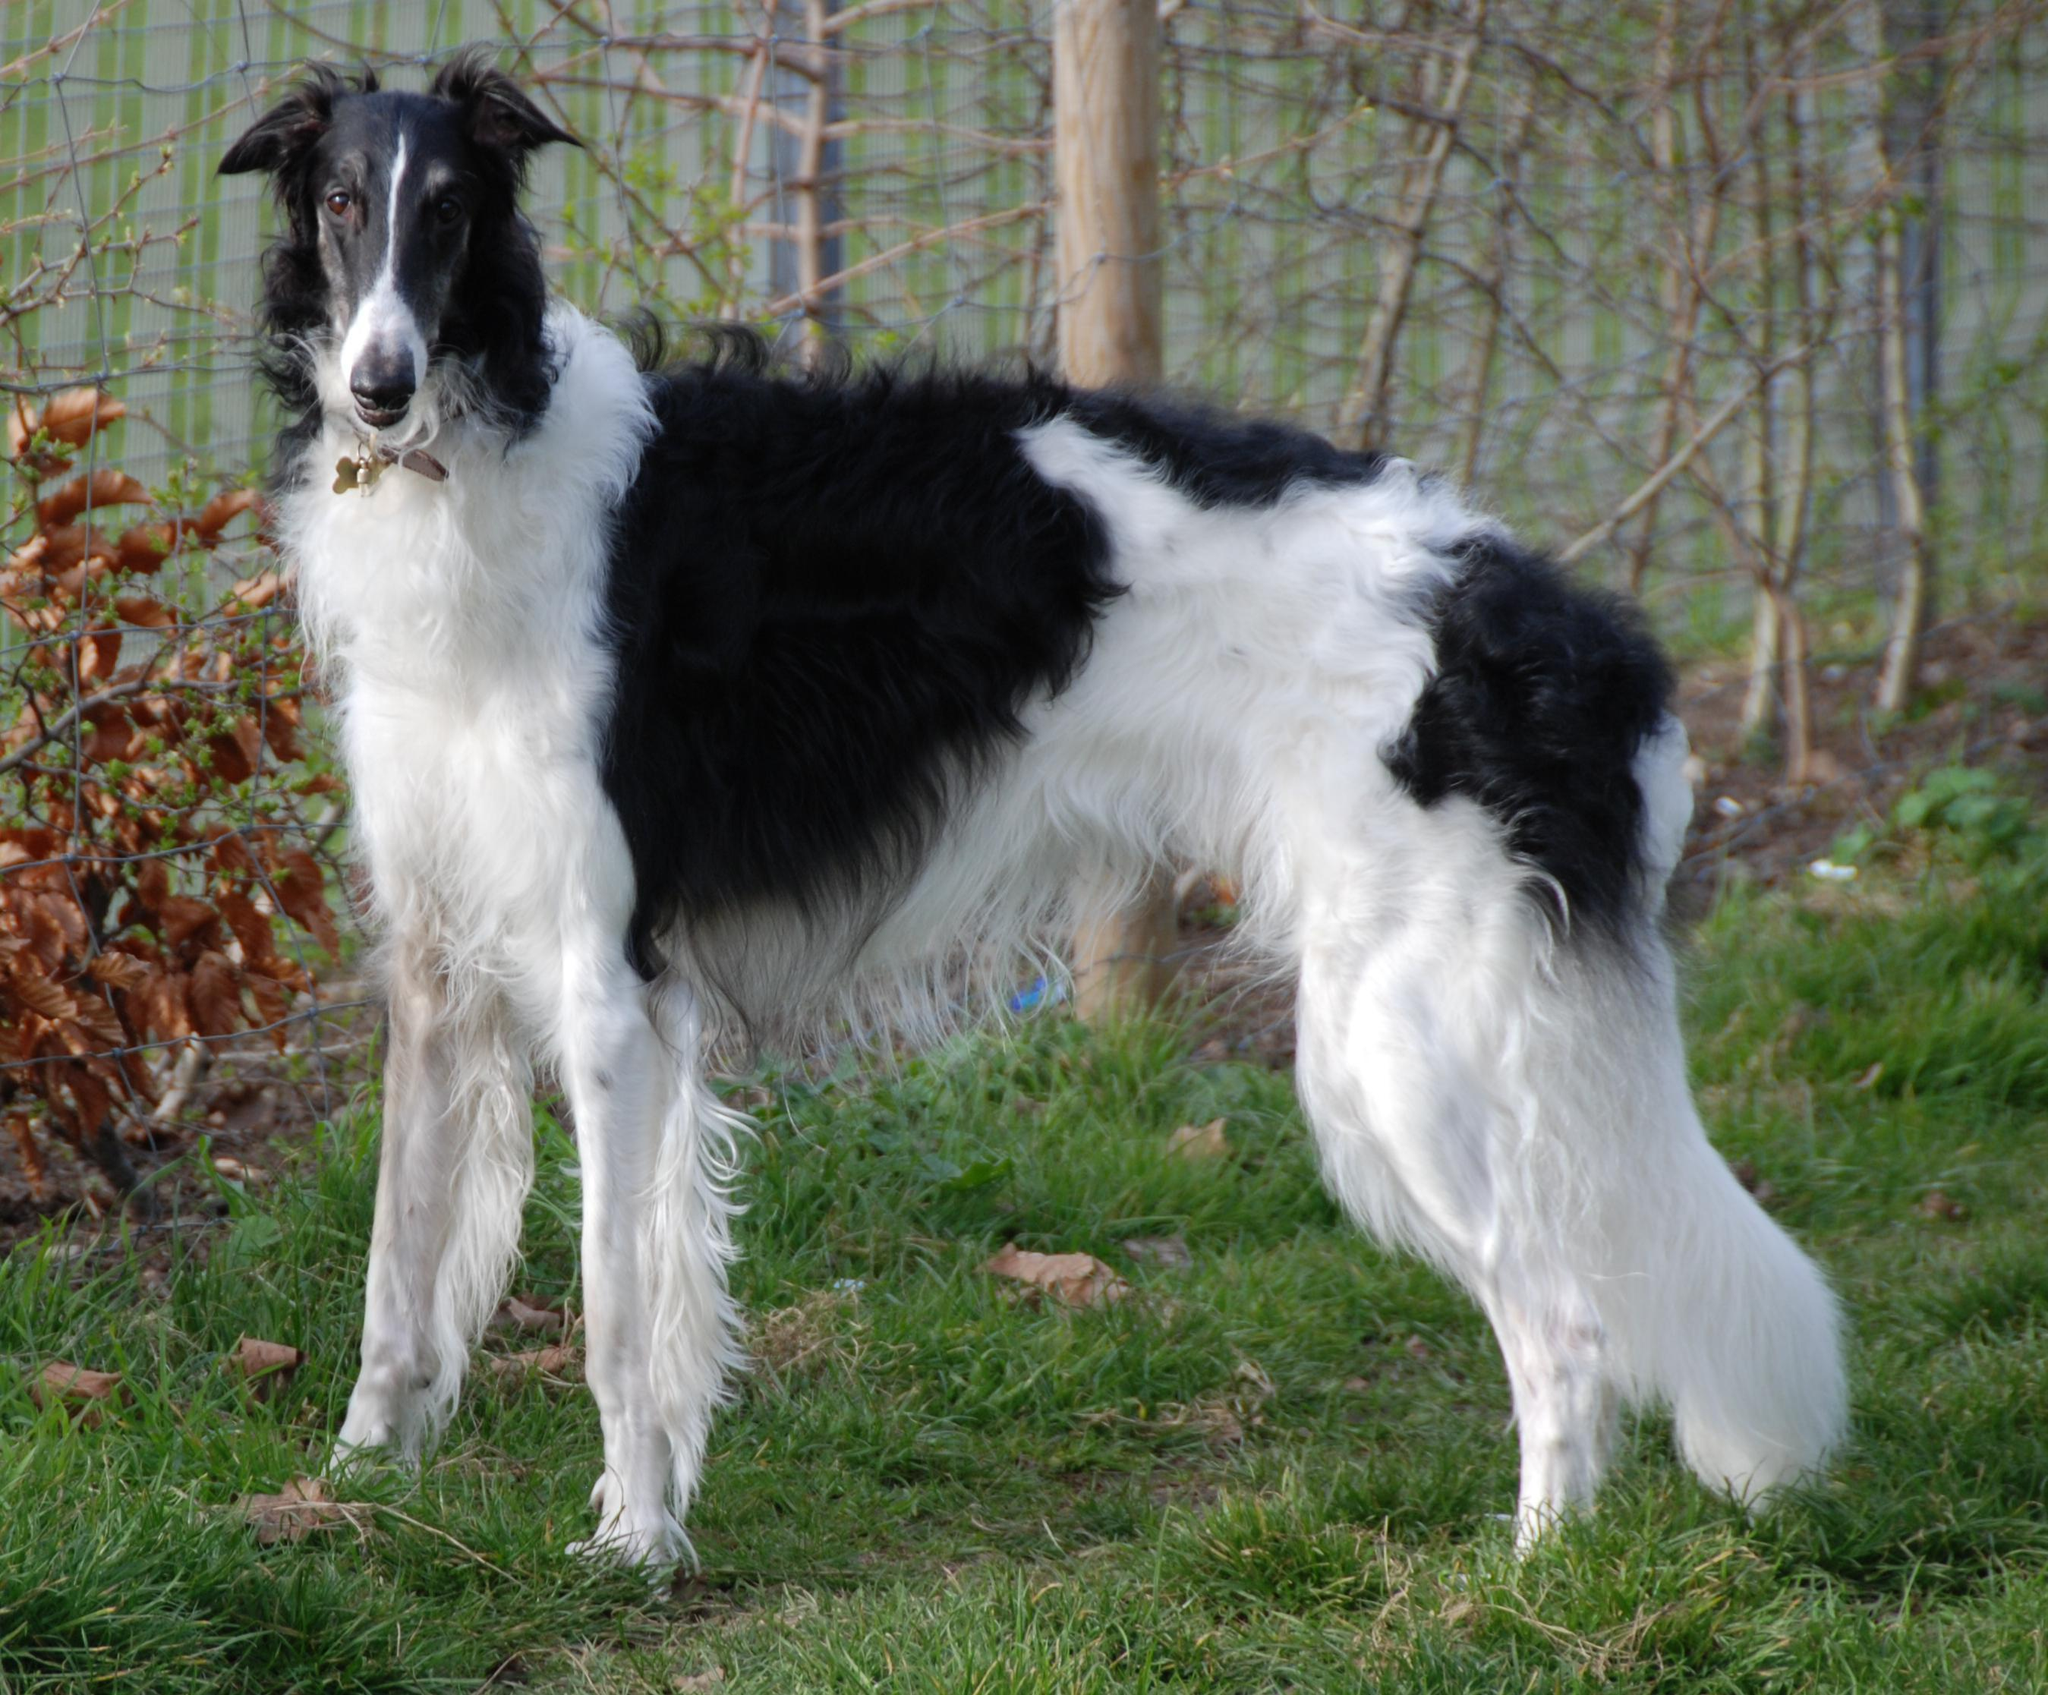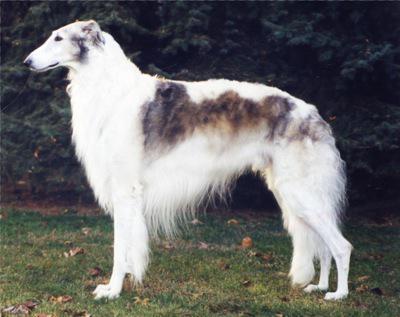The first image is the image on the left, the second image is the image on the right. Given the left and right images, does the statement "All of the dogs are facing the same way." hold true? Answer yes or no. Yes. The first image is the image on the left, the second image is the image on the right. Given the left and right images, does the statement "An image shows at least three hounds sitting upright in a row on green grass." hold true? Answer yes or no. No. The first image is the image on the left, the second image is the image on the right. Given the left and right images, does the statement "There are four dogs in total." hold true? Answer yes or no. No. The first image is the image on the left, the second image is the image on the right. For the images shown, is this caption "All images show hounds standing on the grass." true? Answer yes or no. Yes. 